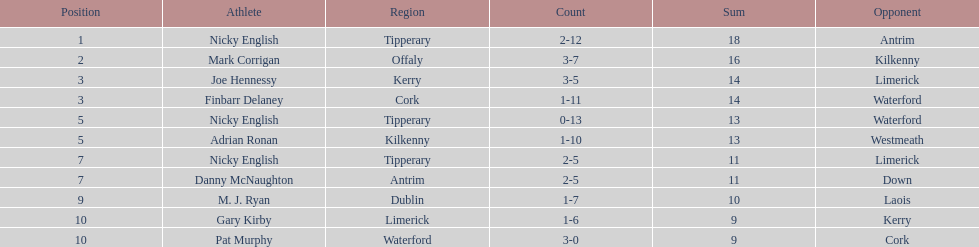Who was the top ranked player in a single game? Nicky English. 